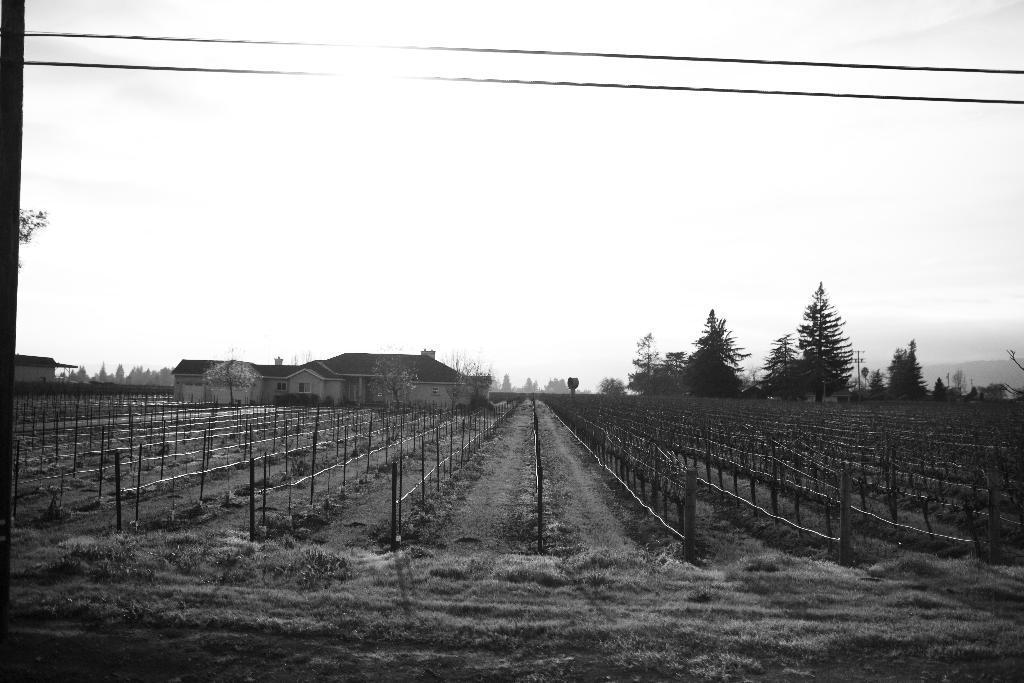In one or two sentences, can you explain what this image depicts? In this image we can see some trees, houses, poles, ropes, wires, grass, also we can see the sky, and the picture is taken in black and white mode. 